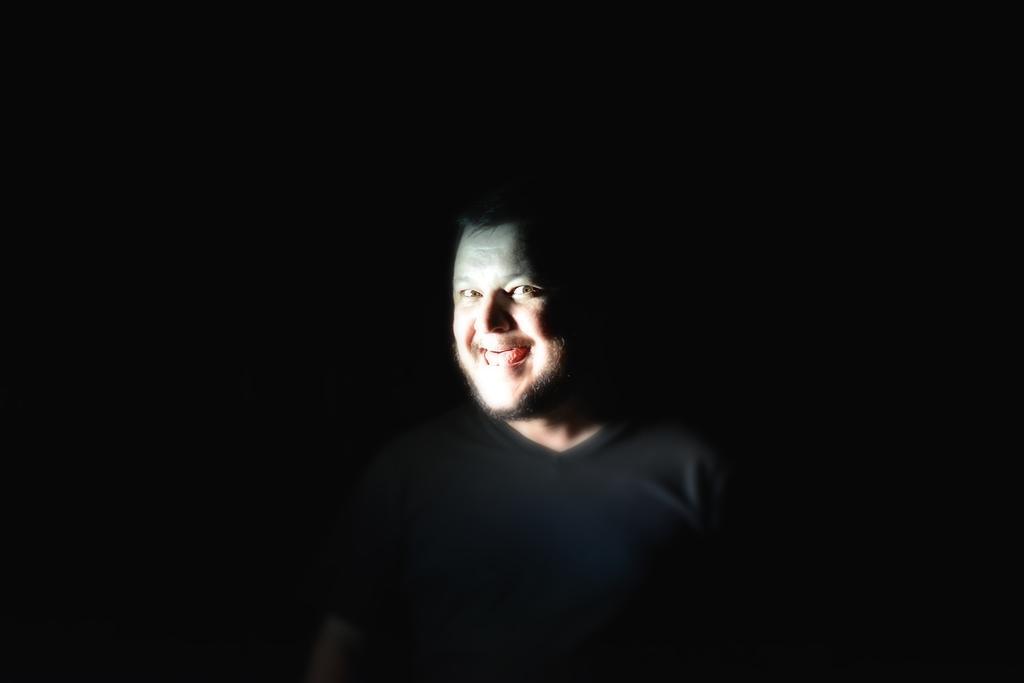Please provide a concise description of this image. In the center of the image we can see a person. 